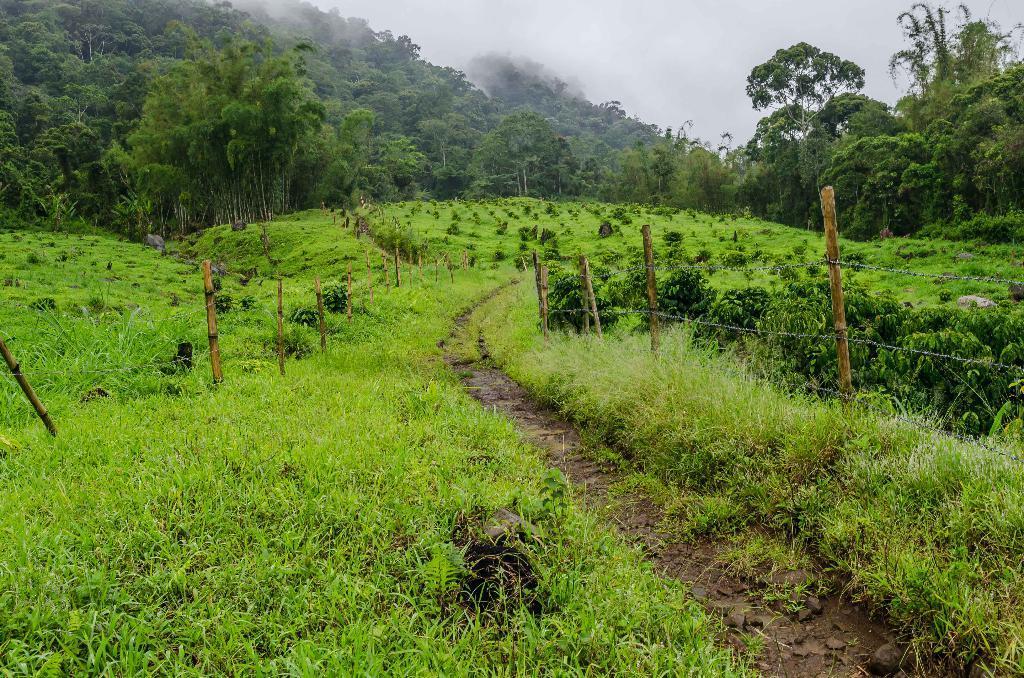How would you summarize this image in a sentence or two? In this image we can see some plants, trees, grass, there are poles, fencing, also we can see the sky. 